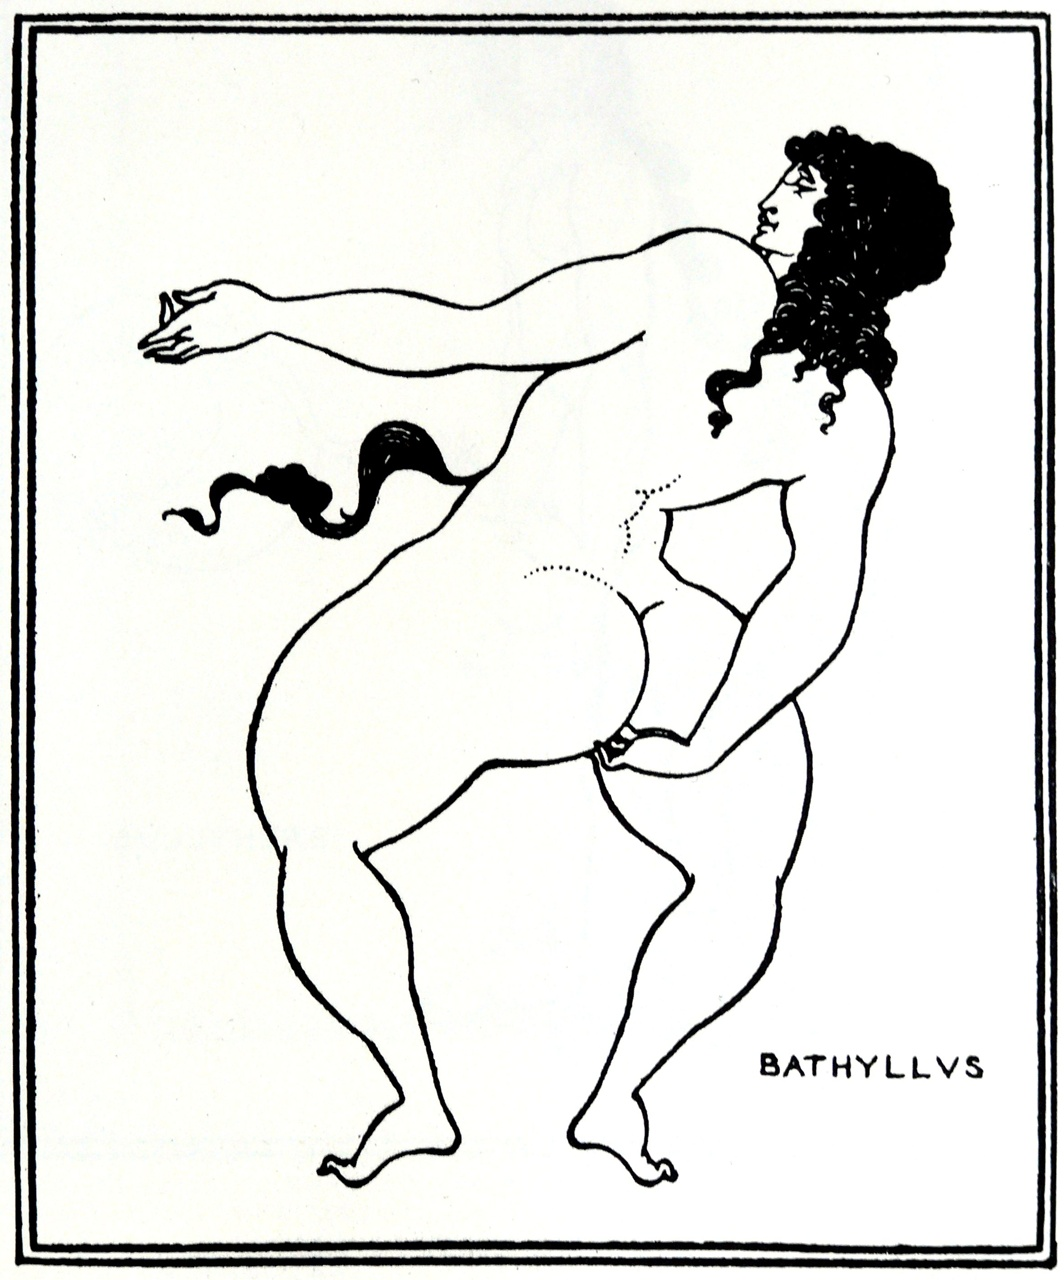Could you compose a short story inspired by this image? In ancient Athens, there lived a young artist named Bathyllus, renowned for his unparalleled beauty and artistic prowess. On a serene afternoon, he stood atop a hill, holding a delicate, newly crafted trinket in his right hand, reminiscent of his first love. His gaze lingered westward, where the golden hues of sunset painted the sky, casting his figure in sharp relief. The hustle of Athens below, where poets and philosophers debated eternal truths, seemed distant. Bathyllus was on a quest - a journey not merely of the body but of the soul, seeking the divine muse that would inspire his next masterpiece. Each motion, from his extended arm to his poised leg, embodied the elegance of his ambitions and the delicate balance between human effort and divine favor. 